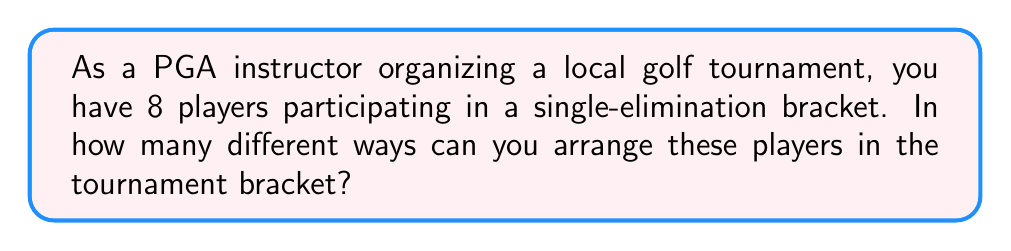Show me your answer to this math problem. To solve this problem, we need to understand that arranging players in a tournament bracket is equivalent to labeling the leaves of a binary tree. Here's the step-by-step solution:

1) In a single-elimination tournament with 8 players, there are 8 positions in the first round of the bracket.

2) The number of ways to arrange 8 players in these 8 positions is simply the number of permutations of 8 players, which is 8!.

3) 8! can be calculated as follows:
   
   $$8! = 8 \times 7 \times 6 \times 5 \times 4 \times 3 \times 2 \times 1 = 40,320$$

4) This result can be understood intuitively:
   - We have 8 choices for the first position
   - 7 choices for the second position
   - 6 choices for the third position
   - And so on, until we have only 1 choice for the last position

5) The multiplication principle states that if we have a series of choices, where the number of choices for each decision is independent of the other choices, we multiply the number of possibilities for each choice.

6) Therefore, the total number of ways to arrange 8 players in the tournament bracket is 40,320.

[asy]
unitsize(1cm);

// Draw the bracket
draw((0,0)--(1,1)--(2,2)--(3,3)--(4,4));
draw((0,8)--(1,7)--(2,6)--(3,5)--(4,4));
draw((0,2)--(1,3)--(2,4));
draw((0,6)--(1,5)--(2,4));
draw((0,1)--(1,2));
draw((0,3)--(1,2));
draw((0,5)--(1,4));
draw((0,7)--(1,6));

// Label the positions
label("1", (-0.5,0));
label("2", (-0.5,1));
label("3", (-0.5,2));
label("4", (-0.5,3));
label("5", (-0.5,5));
label("6", (-0.5,6));
label("7", (-0.5,7));
label("8", (-0.5,8));

[/asy]
Answer: $40,320$ ways 